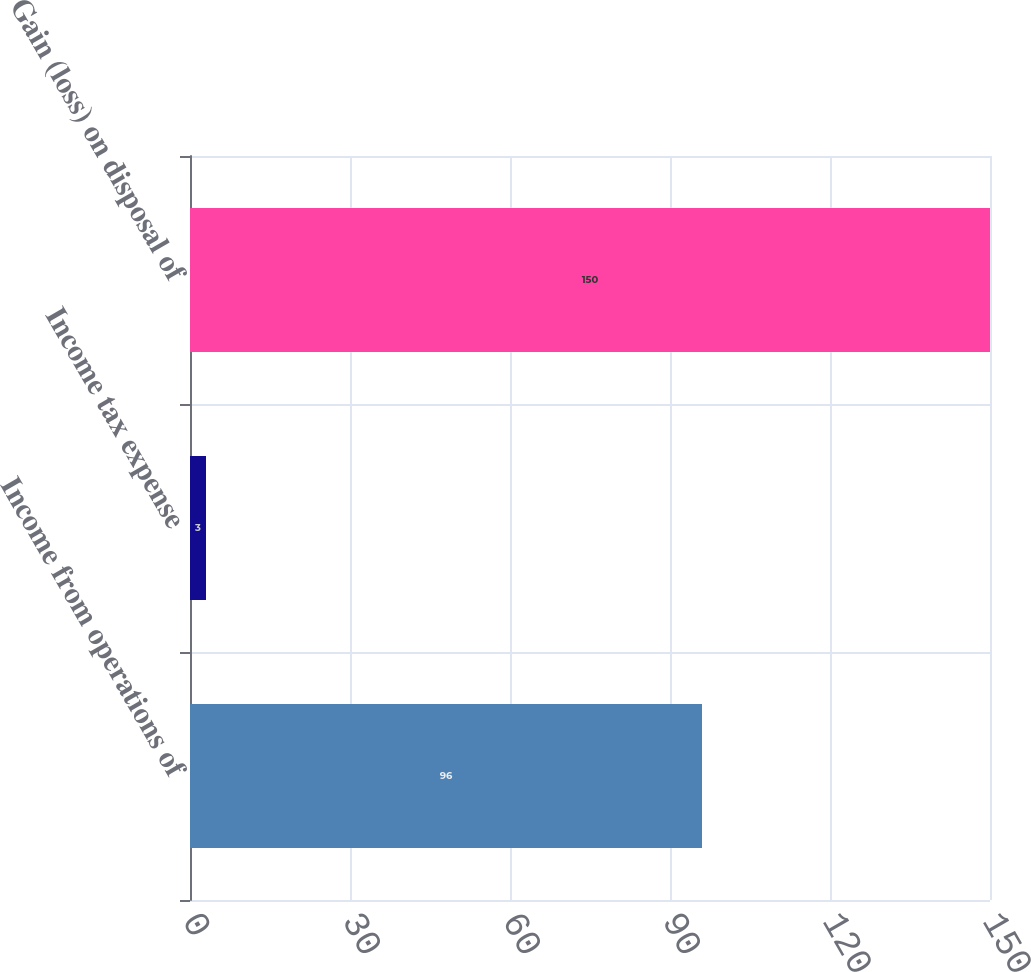Convert chart. <chart><loc_0><loc_0><loc_500><loc_500><bar_chart><fcel>Income from operations of<fcel>Income tax expense<fcel>Gain (loss) on disposal of<nl><fcel>96<fcel>3<fcel>150<nl></chart> 